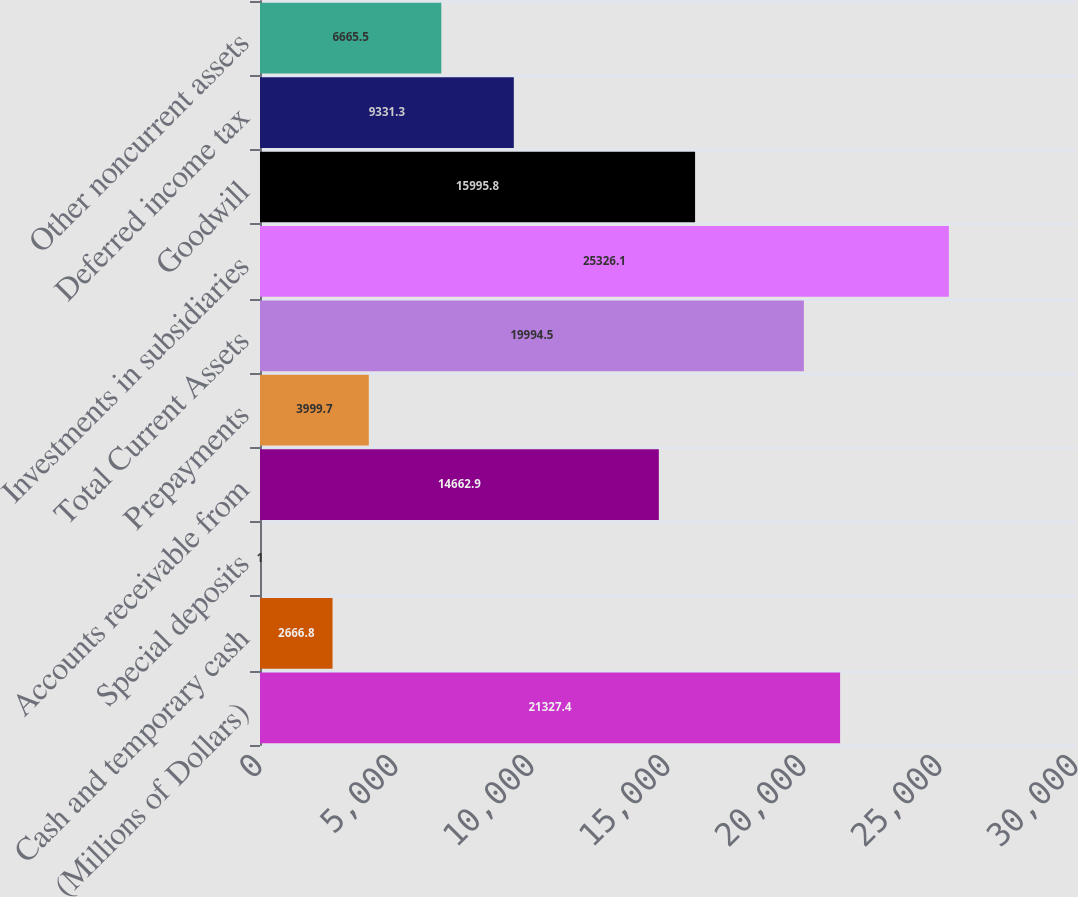Convert chart. <chart><loc_0><loc_0><loc_500><loc_500><bar_chart><fcel>(Millions of Dollars)<fcel>Cash and temporary cash<fcel>Special deposits<fcel>Accounts receivable from<fcel>Prepayments<fcel>Total Current Assets<fcel>Investments in subsidiaries<fcel>Goodwill<fcel>Deferred income tax<fcel>Other noncurrent assets<nl><fcel>21327.4<fcel>2666.8<fcel>1<fcel>14662.9<fcel>3999.7<fcel>19994.5<fcel>25326.1<fcel>15995.8<fcel>9331.3<fcel>6665.5<nl></chart> 